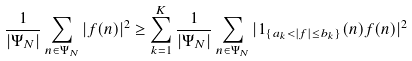Convert formula to latex. <formula><loc_0><loc_0><loc_500><loc_500>\frac { 1 } { | \Psi _ { N } | } \sum _ { n \in \Psi _ { N } } | f ( n ) | ^ { 2 } \geq \sum _ { k = 1 } ^ { K } \frac { 1 } { | \Psi _ { N } | } \sum _ { n \in \Psi _ { N } } | 1 _ { \{ a _ { k } < | f | \leq b _ { k } \} } ( n ) f ( n ) | ^ { 2 }</formula> 